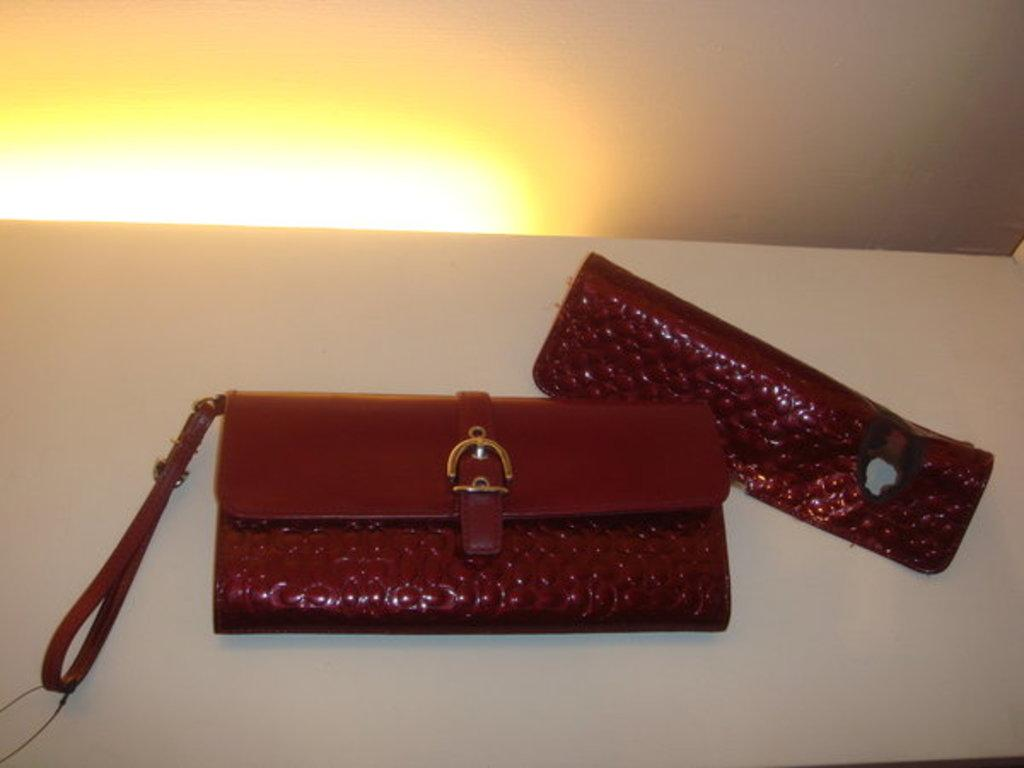How many wallets are visible in the image? There are two wallets in the image. Where are the wallets located? The wallets are on a table. Are there any ants crawling on the wallets in the image? There is no mention of ants in the image, so we cannot determine if they are present or not. 